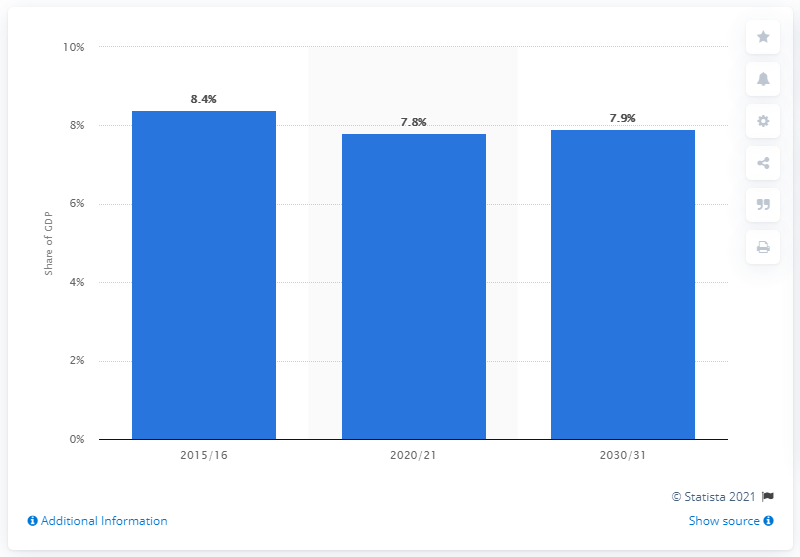Give some essential details in this illustration. In 2015/16, it was projected that the NHS and adult social care would receive approximately 8.4% of the total GDP allocation. 